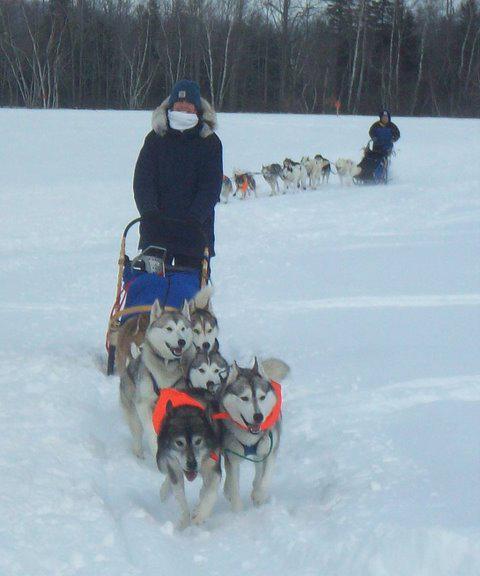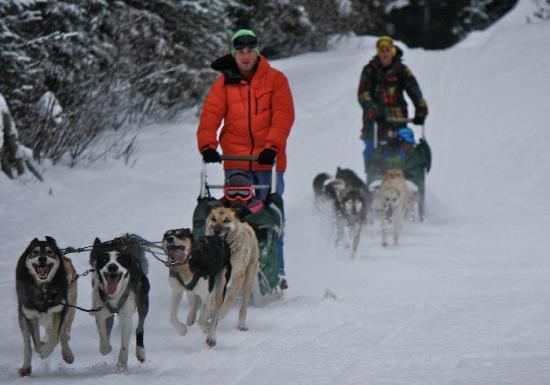The first image is the image on the left, the second image is the image on the right. For the images shown, is this caption "The person in the image on the left is wearing a red jacket." true? Answer yes or no. No. The first image is the image on the left, the second image is the image on the right. For the images displayed, is the sentence "In one photo dogs are running, and in the other, they are still." factually correct? Answer yes or no. No. 